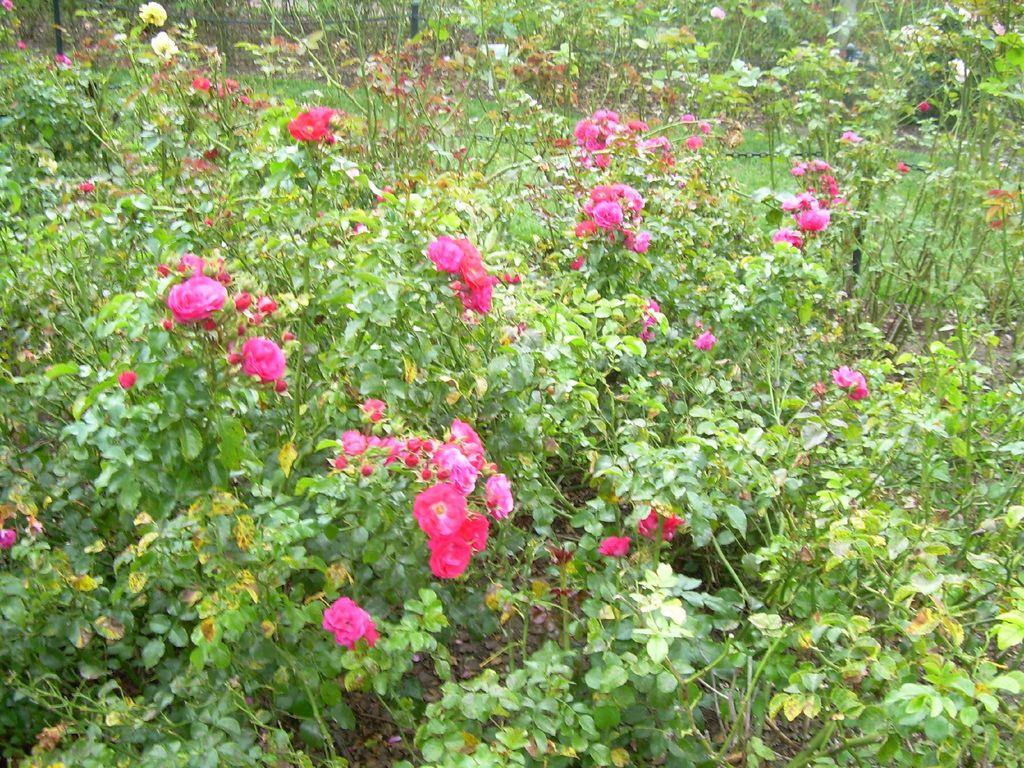What type of living organisms can be seen in the image? There are flowers and plants in the image. Where are the flowers and plants located? The flowers and plants are on the ground. What type of hospital can be seen in the image? There is no hospital present in the image; it features flowers and plants on the ground. Can you tell me how many bees are interacting with the flowers in the image? There are no bees present in the image; it only features flowers and plants on the ground. 